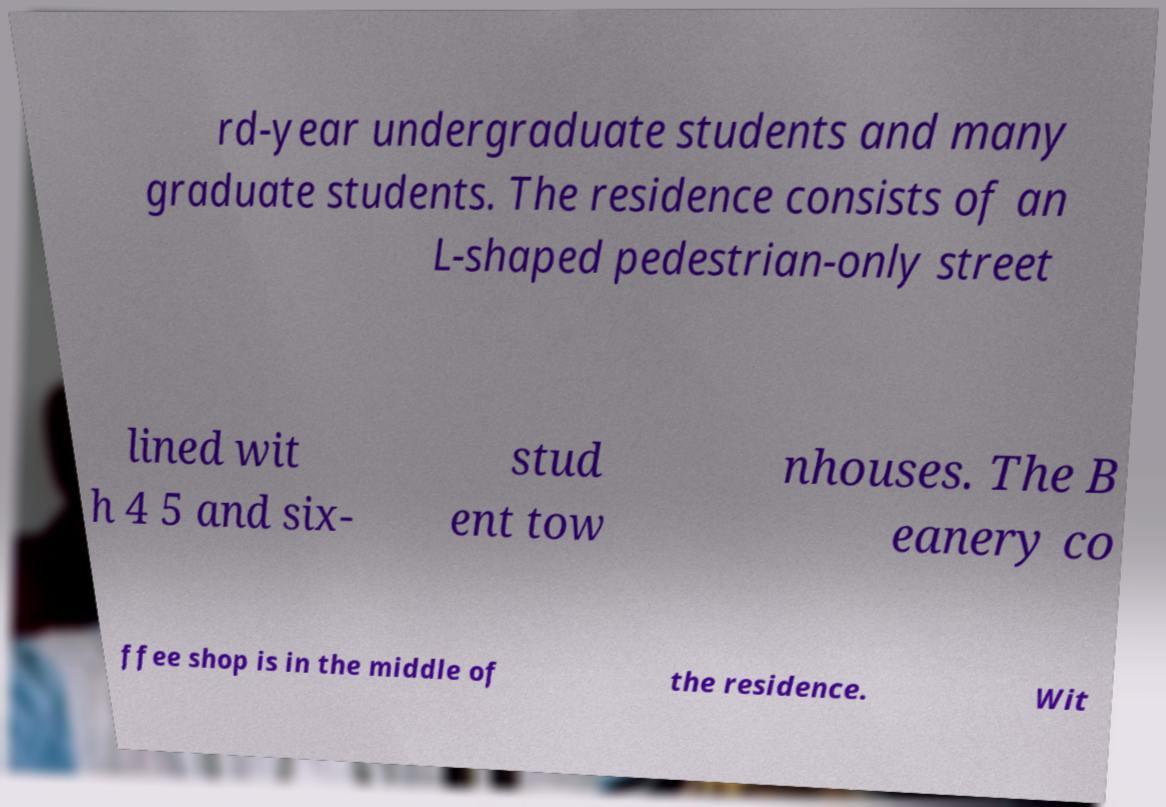Please identify and transcribe the text found in this image. rd-year undergraduate students and many graduate students. The residence consists of an L-shaped pedestrian-only street lined wit h 4 5 and six- stud ent tow nhouses. The B eanery co ffee shop is in the middle of the residence. Wit 